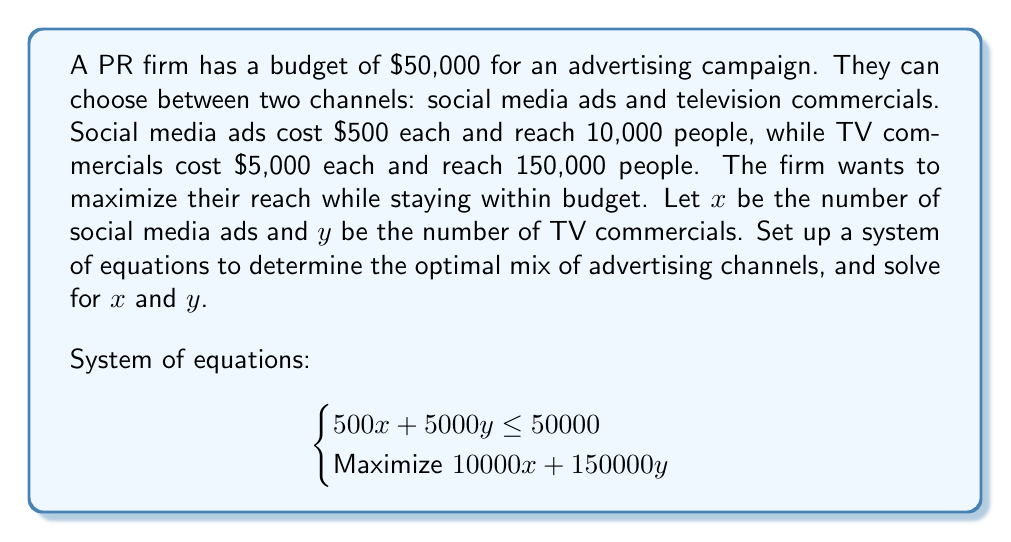Can you solve this math problem? To solve this problem, we'll follow these steps:

1) First, we need to understand the constraints:
   - Budget constraint: $500x + 5000y \leq 50000$
   - Non-negative constraint: $x \geq 0$ and $y \geq 0$

2) The objective is to maximize the reach: $10000x + 150000y$

3) To find the optimal solution, we need to consider the extreme points of the feasible region:

   a) $(x,y) = (0,10)$: All budget on TV commercials
      Reach = $10 \times 150000 = 1,500,000$

   b) $(x,y) = (100,0)$: All budget on social media ads
      Reach = $100 \times 10000 = 1,000,000$

   c) The point where both channels are used, satisfying:
      $500x + 5000y = 50000$

4) To find point c, we can solve:
   $500x + 5000y = 50000$
   $x + 10y = 100$

5) We can express $x$ in terms of $y$:
   $x = 100 - 10y$

6) Substituting this into the reach function:
   Reach $= 10000(100-10y) + 150000y$
   $= 1000000 - 100000y + 150000y$
   $= 1000000 + 50000y$

7) This is a linear function in $y$, which increases as $y$ increases. Therefore, the maximum reach will occur at the highest feasible value of $y$.

8) The highest feasible value of $y$ is 10, which corresponds to $x = 0$.

Therefore, the optimal solution is to use all the budget on TV commercials: $x = 0$, $y = 10$.
Answer: The optimal mix is 0 social media ads and 10 TV commercials, resulting in a maximum reach of 1,500,000 people. 